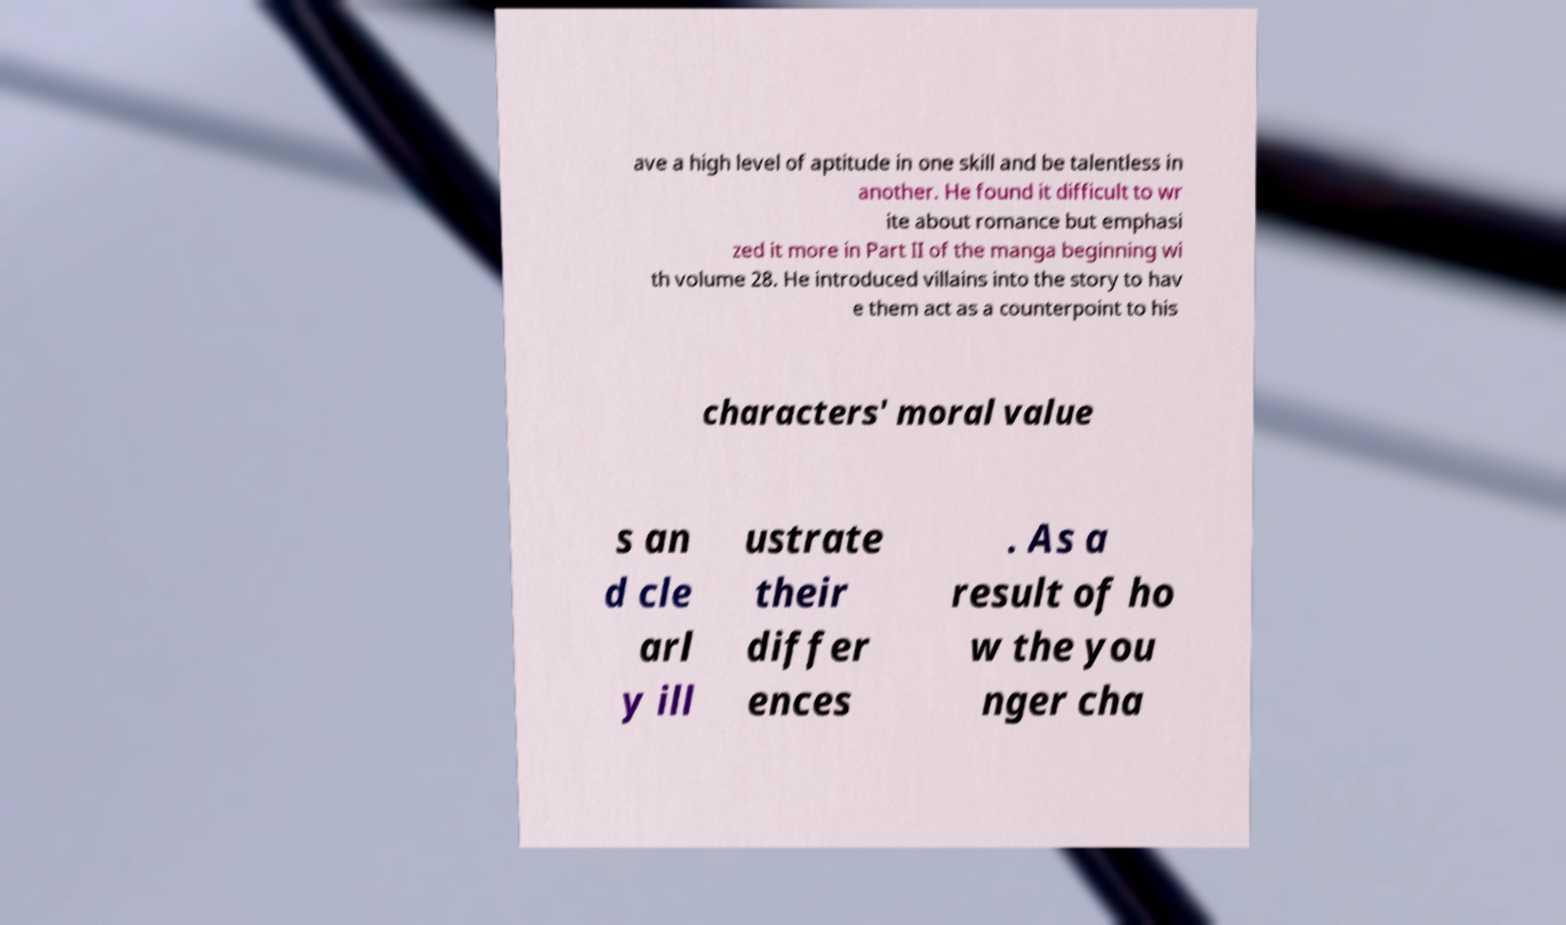For documentation purposes, I need the text within this image transcribed. Could you provide that? ave a high level of aptitude in one skill and be talentless in another. He found it difficult to wr ite about romance but emphasi zed it more in Part II of the manga beginning wi th volume 28. He introduced villains into the story to hav e them act as a counterpoint to his characters' moral value s an d cle arl y ill ustrate their differ ences . As a result of ho w the you nger cha 